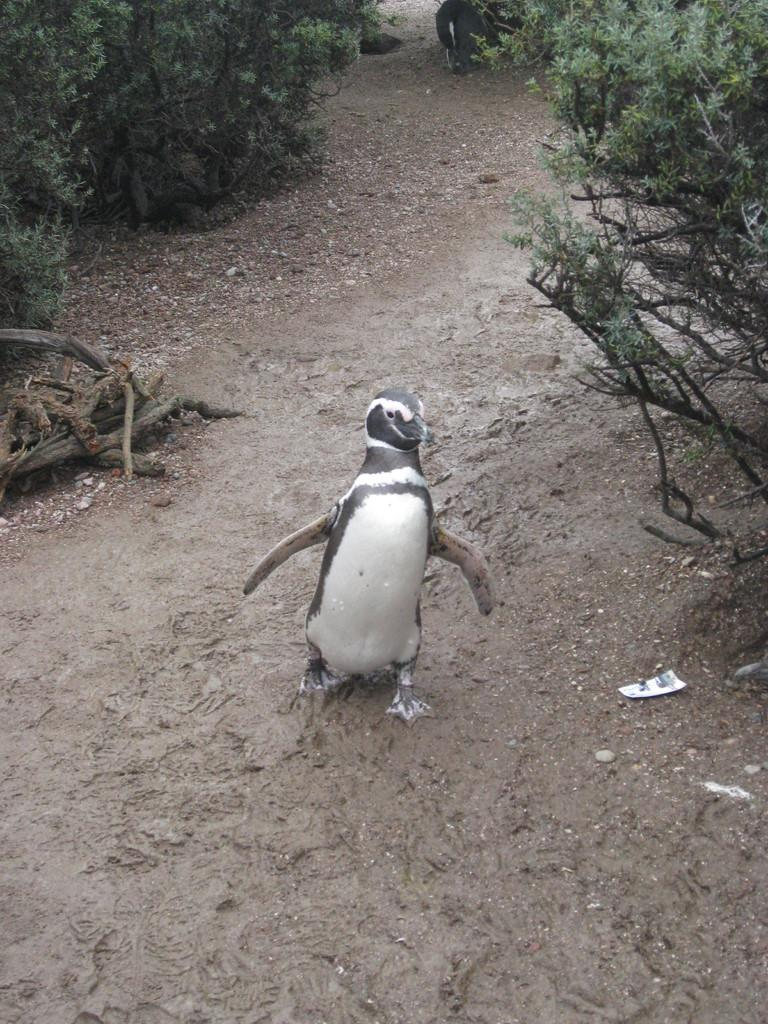What animal is present in the image? There is a penguin in the image. What is the penguin doing in the image? The penguin is walking in the mud. What can be seen in the background of the image? There are plants visible at the top of the image. What advice does the penguin give to the other animals in the image? There are no other animals present in the image, and the penguin does not give any advice. 